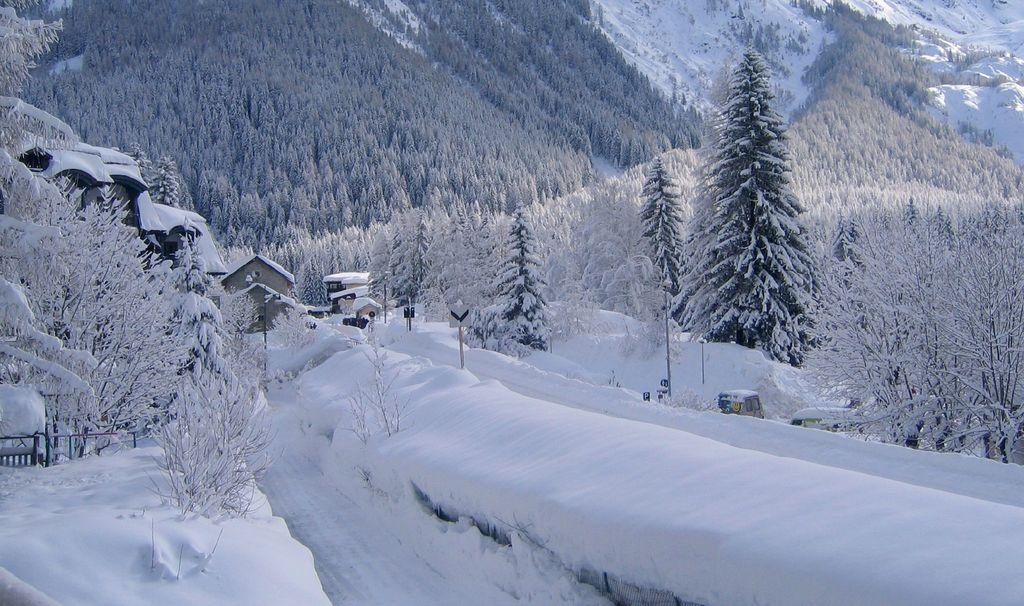What type of natural environment is depicted in the image? The image contains many trees covered with snow, indicating a winter landscape. Can you describe the ground in the image? There is snow at the bottom of the image. What type of structures can be seen in the image? There are houses visible in the front of the image. What is visible in the distance in the image? There are mountains in the background of the image. What color is the beast that is hiding behind the trees in the image? There is no beast present in the image; it only features snow-covered trees, houses, and mountains. 